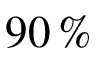Convert formula to latex. <formula><loc_0><loc_0><loc_500><loc_500>9 0 \, \%</formula> 